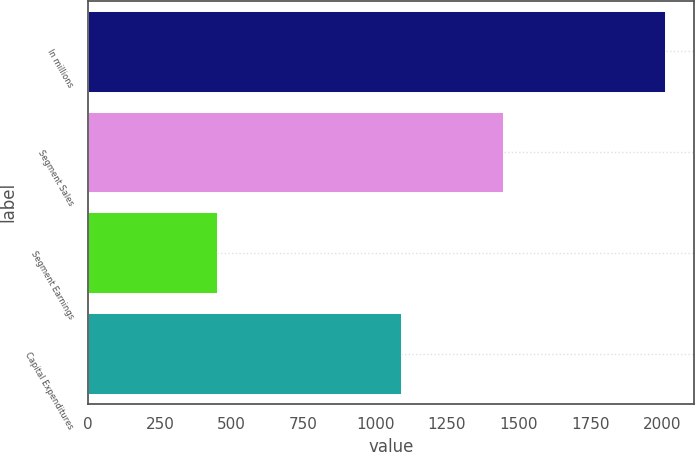Convert chart to OTSL. <chart><loc_0><loc_0><loc_500><loc_500><bar_chart><fcel>In millions<fcel>Segment Sales<fcel>Segment Earnings<fcel>Capital Expenditures<nl><fcel>2011<fcel>1447<fcel>448<fcel>1089<nl></chart> 